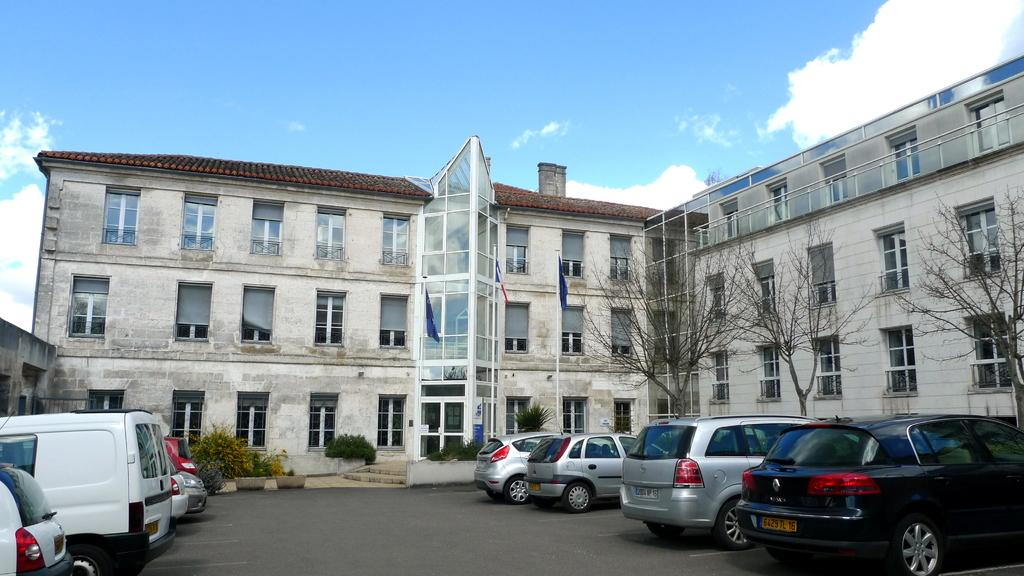What type of structures can be seen in the image? There are buildings in the image. What architectural features are present in the buildings? There are windows in the image. What national symbols are visible in the image? There are flags in the image. What type of vegetation is present in the image? There are dry trees in the image. What type of pathway is present in the image? There are stairs in the image. What type of transportation is visible in the image? There are vehicles on the road in the image. What is the color of the sky in the image? The sky is in white and blue color. What type of work does the carpenter do in the image? There is no carpenter present in the image. What type of collar is visible on the dog in the image? There is no dog or collar present in the image. 